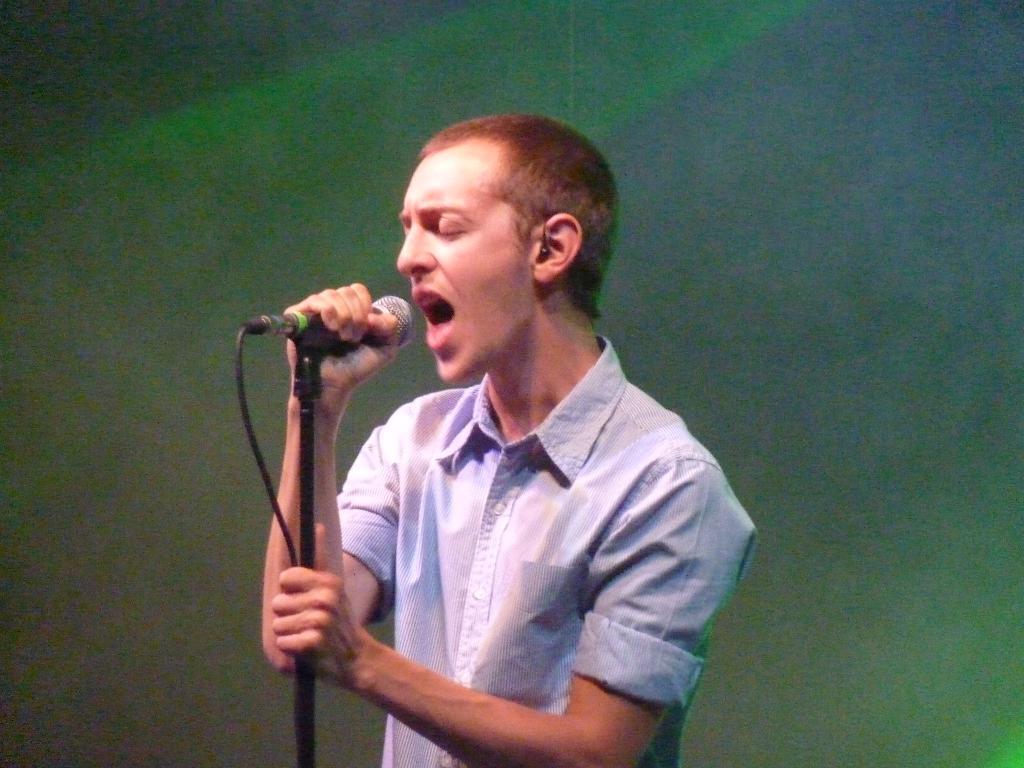Could you give a brief overview of what you see in this image? In this image the background is green in color. In the middle of the image a boy is singing and he is holding a mic in his hands. 